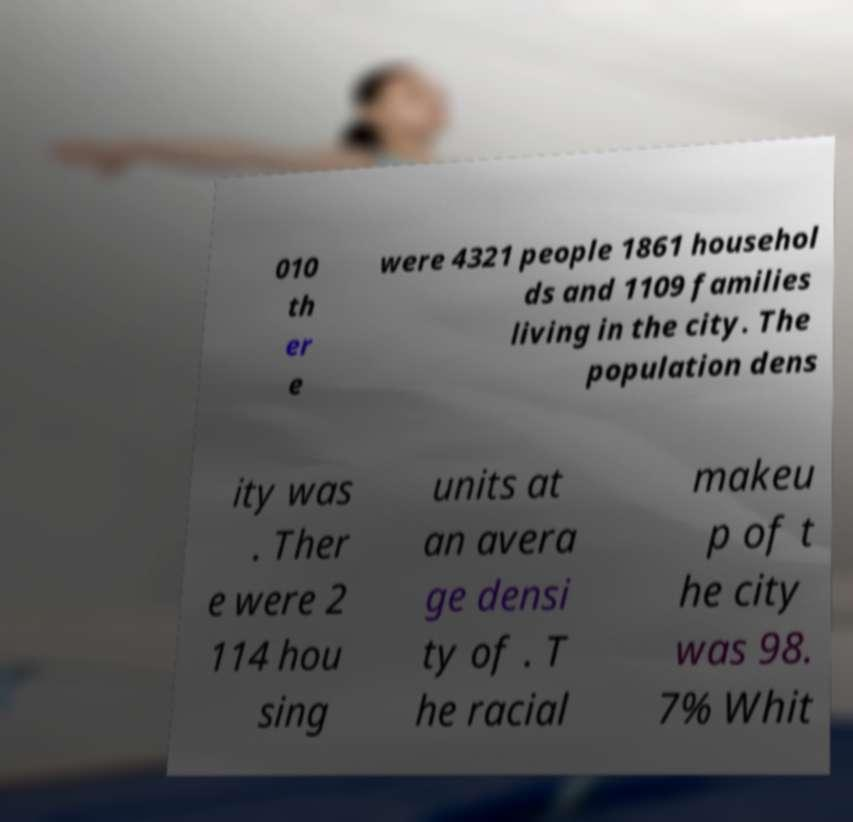Can you accurately transcribe the text from the provided image for me? 010 th er e were 4321 people 1861 househol ds and 1109 families living in the city. The population dens ity was . Ther e were 2 114 hou sing units at an avera ge densi ty of . T he racial makeu p of t he city was 98. 7% Whit 